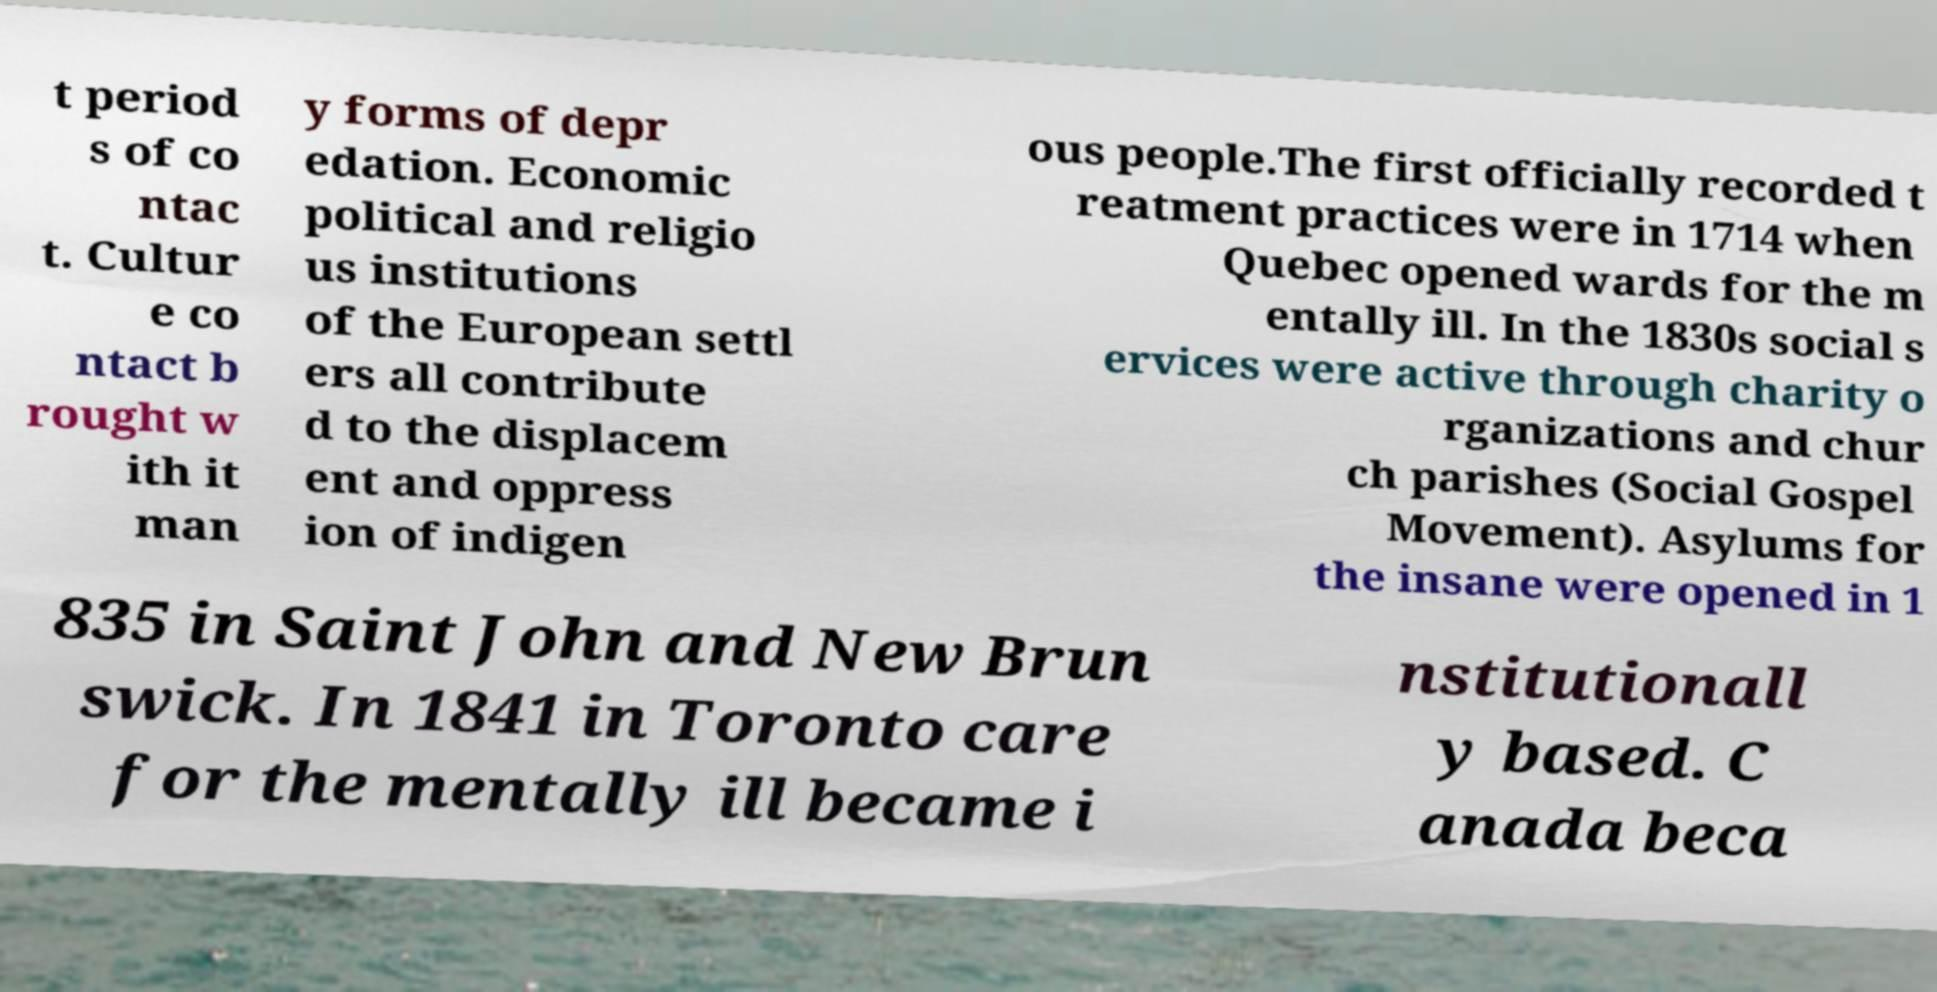Please identify and transcribe the text found in this image. t period s of co ntac t. Cultur e co ntact b rought w ith it man y forms of depr edation. Economic political and religio us institutions of the European settl ers all contribute d to the displacem ent and oppress ion of indigen ous people.The first officially recorded t reatment practices were in 1714 when Quebec opened wards for the m entally ill. In the 1830s social s ervices were active through charity o rganizations and chur ch parishes (Social Gospel Movement). Asylums for the insane were opened in 1 835 in Saint John and New Brun swick. In 1841 in Toronto care for the mentally ill became i nstitutionall y based. C anada beca 